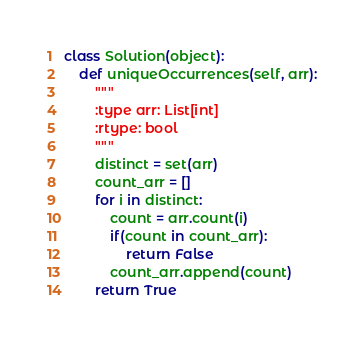<code> <loc_0><loc_0><loc_500><loc_500><_Python_>class Solution(object):
    def uniqueOccurrences(self, arr):
        """
        :type arr: List[int]
        :rtype: bool
        """
        distinct = set(arr)
        count_arr = []
        for i in distinct:
            count = arr.count(i)
            if(count in count_arr):
                return False
            count_arr.append(count)
        return True
</code> 